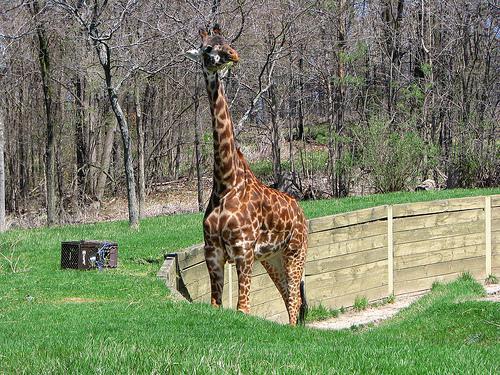How many giraffes are seen?
Give a very brief answer. 1. 